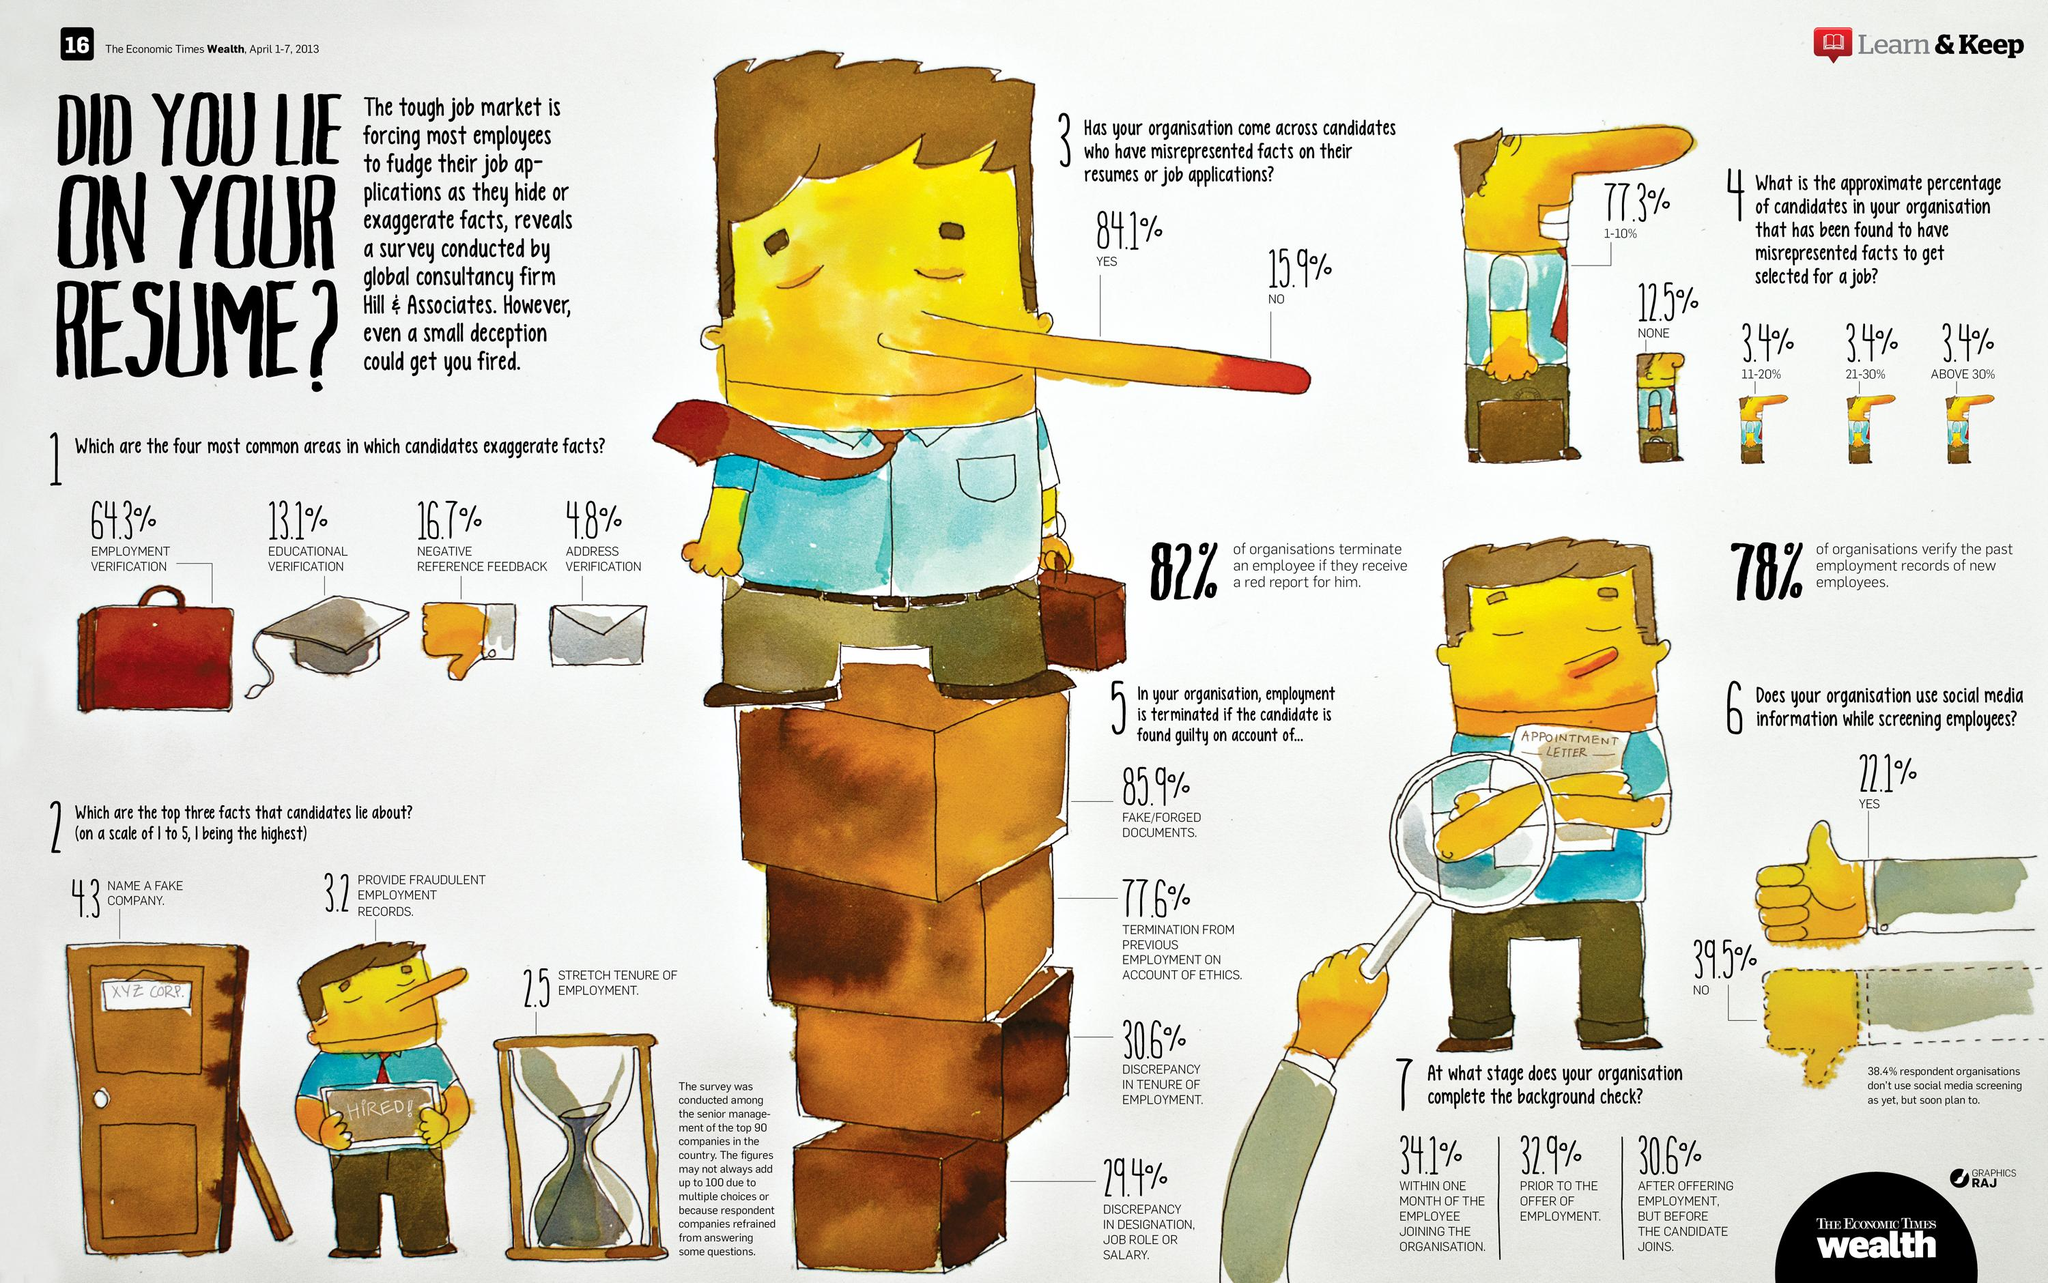Draw attention to some important aspects in this diagram. The third reason for employment termination is due to a discrepancy in the length of employment. The name written on the door is XYZ CORP. The facts in educational verification are the least exaggerated. According to the data, only 12.5% of the candidates have not misrepresented facts. According to the data provided, approximately 77.9% of organizations that do not or plan to use social media while screening employees have a combined sum. 